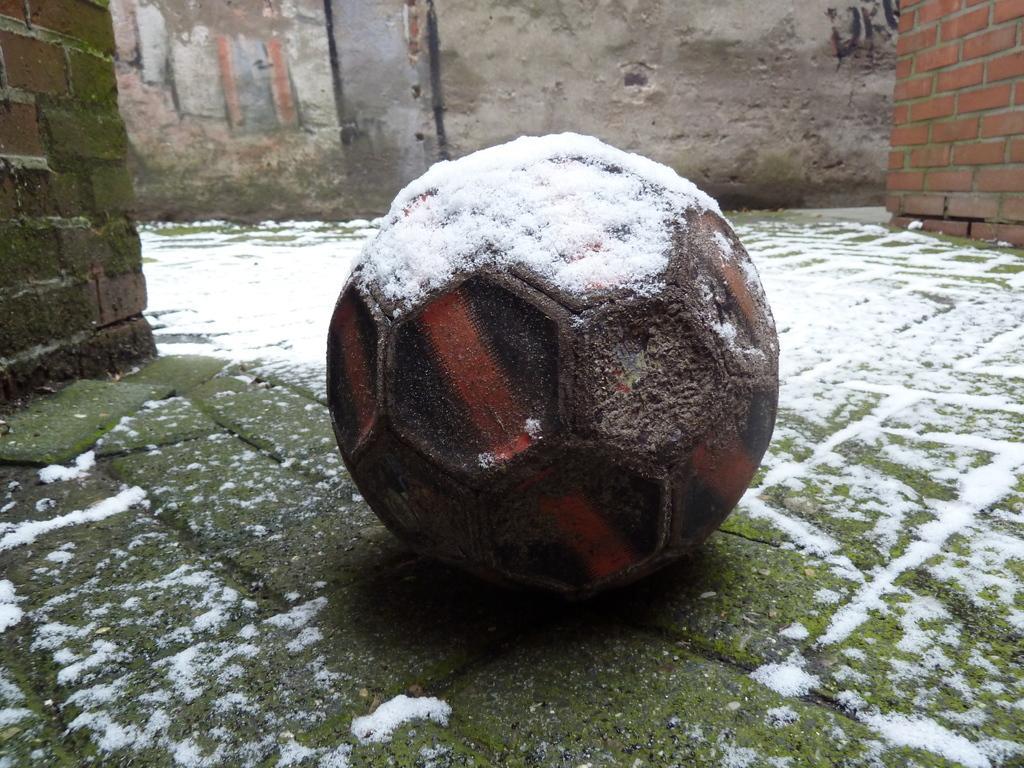Could you give a brief overview of what you see in this image? In this picture there is a ball in the center of the image, on which there is snow. 